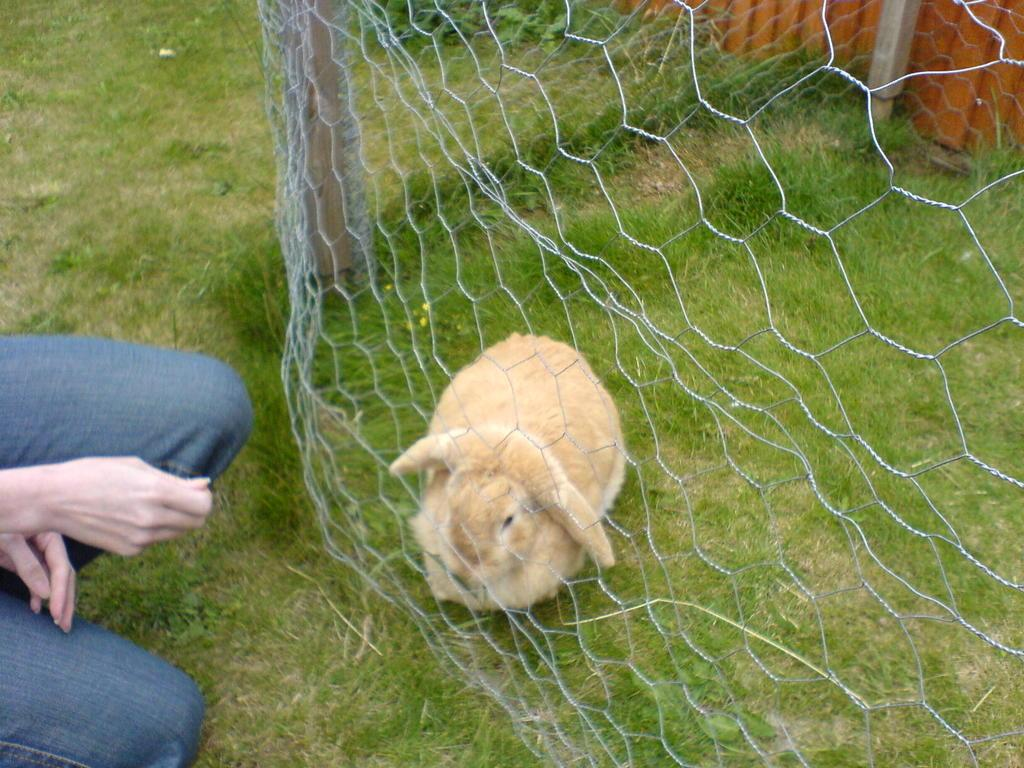What animal can be seen in the image? There is a rabbit in the image. What type of vegetation is present on the ground in the image? There is grass on the ground in the image. What type of barrier is present in the image? There is mesh fencing in the image. Can you describe the person visible in the image? Only a part of a person is visible on the left side of the image. What other type of barrier is present in the image? There is another fencing at the top of the image. What type of bean is growing on the mesh fencing in the image? There are no beans present in the image, and the mesh fencing is not a support for growing plants. 